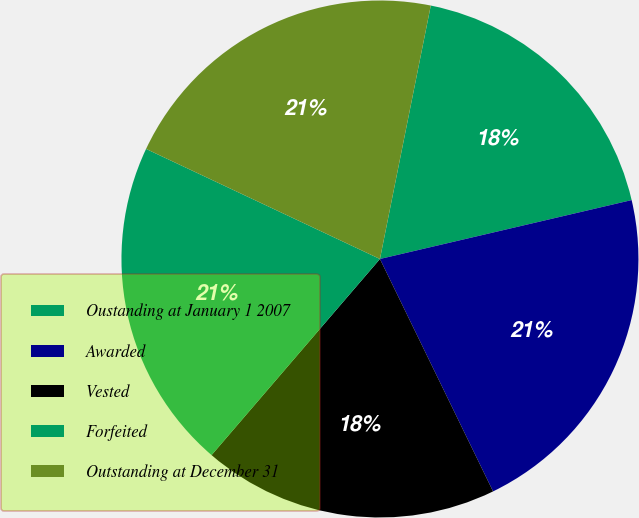Convert chart. <chart><loc_0><loc_0><loc_500><loc_500><pie_chart><fcel>Oustanding at January 1 2007<fcel>Awarded<fcel>Vested<fcel>Forfeited<fcel>Outstanding at December 31<nl><fcel>18.19%<fcel>21.45%<fcel>18.5%<fcel>20.71%<fcel>21.15%<nl></chart> 